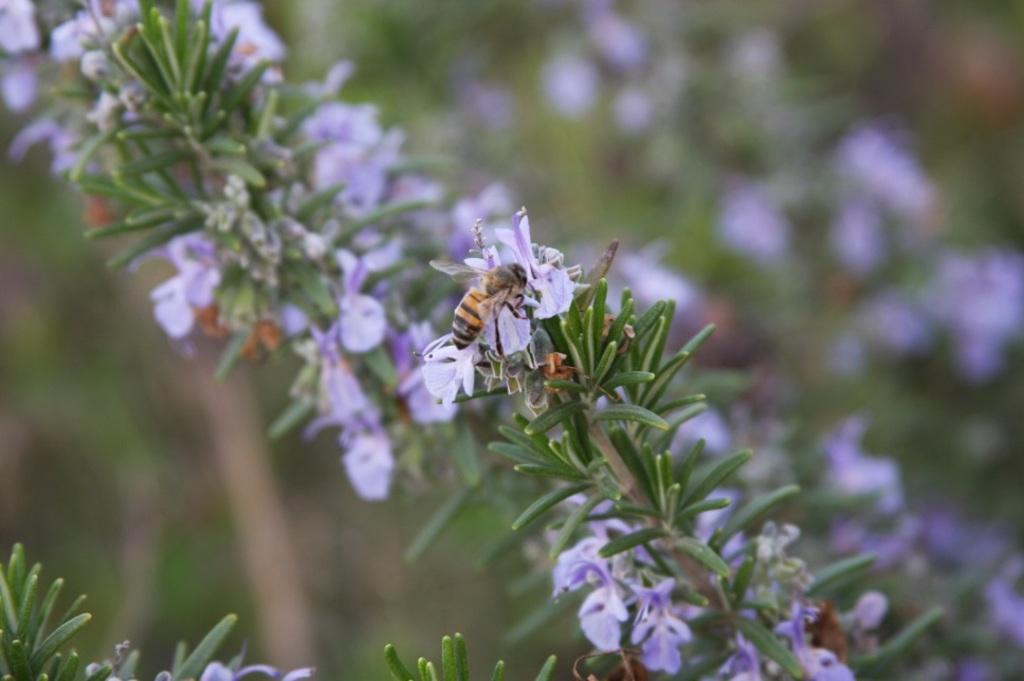In one or two sentences, can you explain what this image depicts? In this image there are plants and we can see flowers. In the center there is a bee on the flower. 